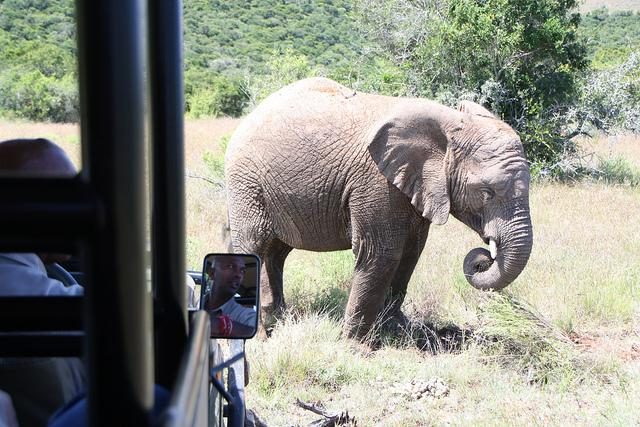What type of vehicle is the man on the left most likely riding in? jeep 